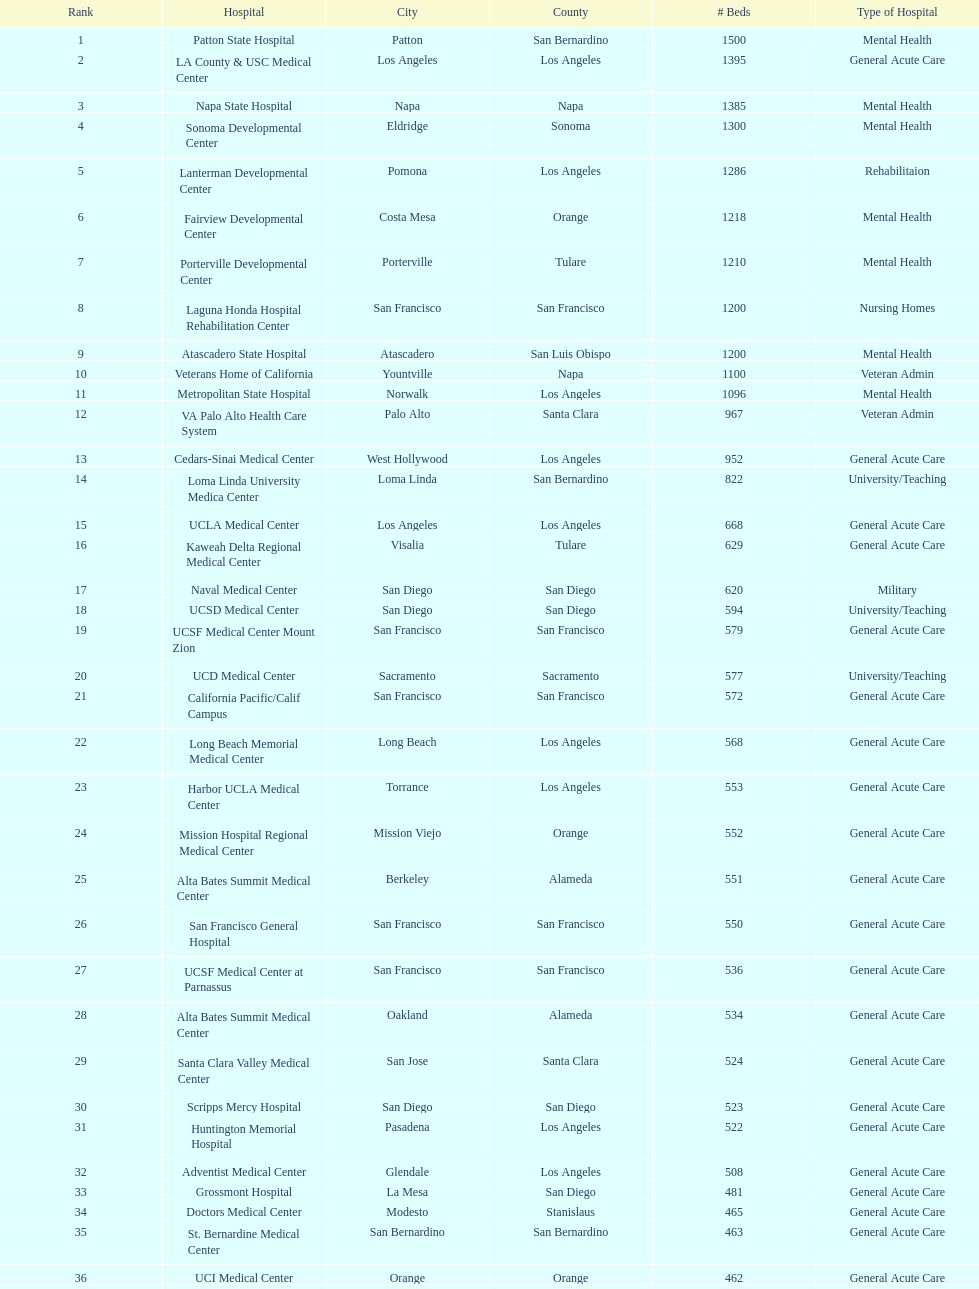By how many beds did the largest hospital in california exceed the size of the 50th largest hospital? 1071. 